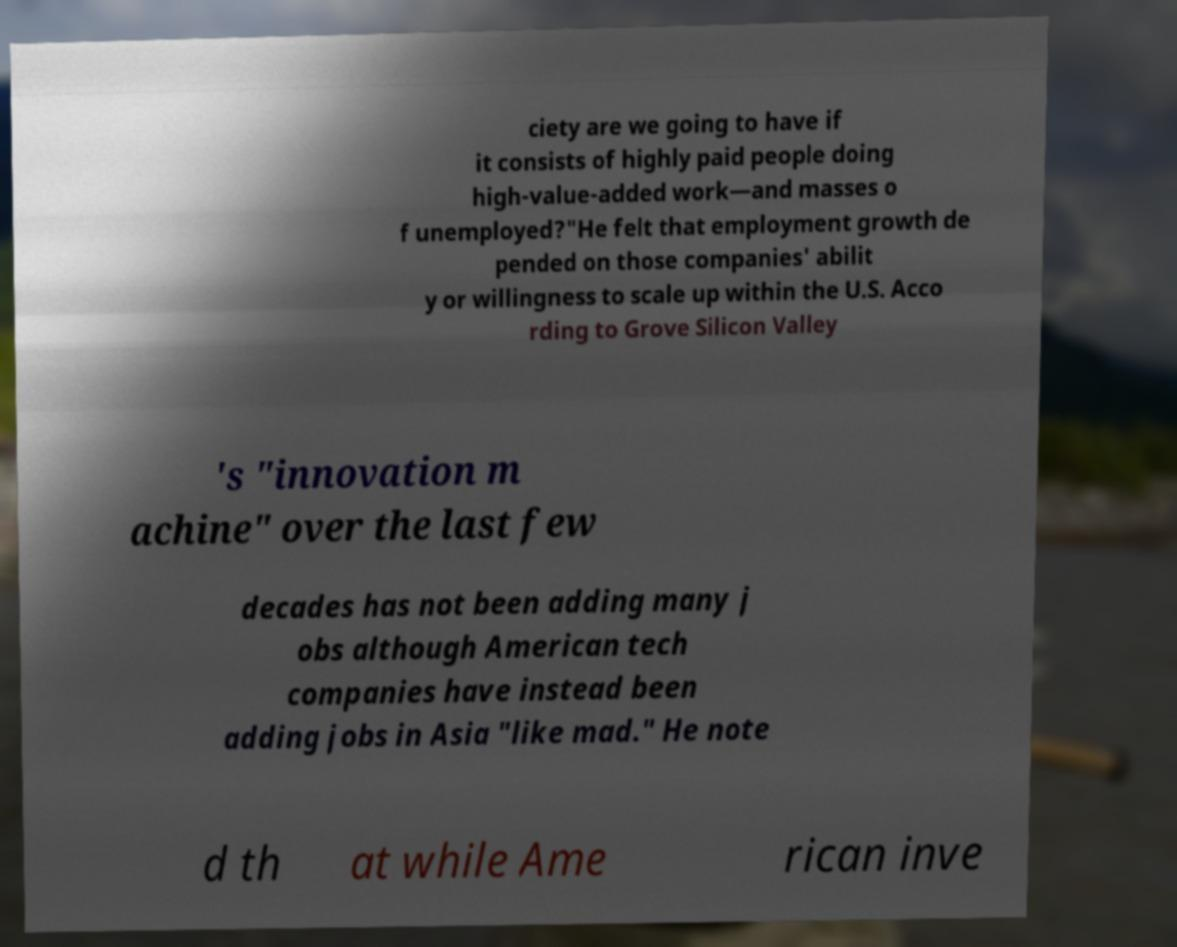Please read and relay the text visible in this image. What does it say? ciety are we going to have if it consists of highly paid people doing high-value-added work—and masses o f unemployed?"He felt that employment growth de pended on those companies' abilit y or willingness to scale up within the U.S. Acco rding to Grove Silicon Valley 's "innovation m achine" over the last few decades has not been adding many j obs although American tech companies have instead been adding jobs in Asia "like mad." He note d th at while Ame rican inve 